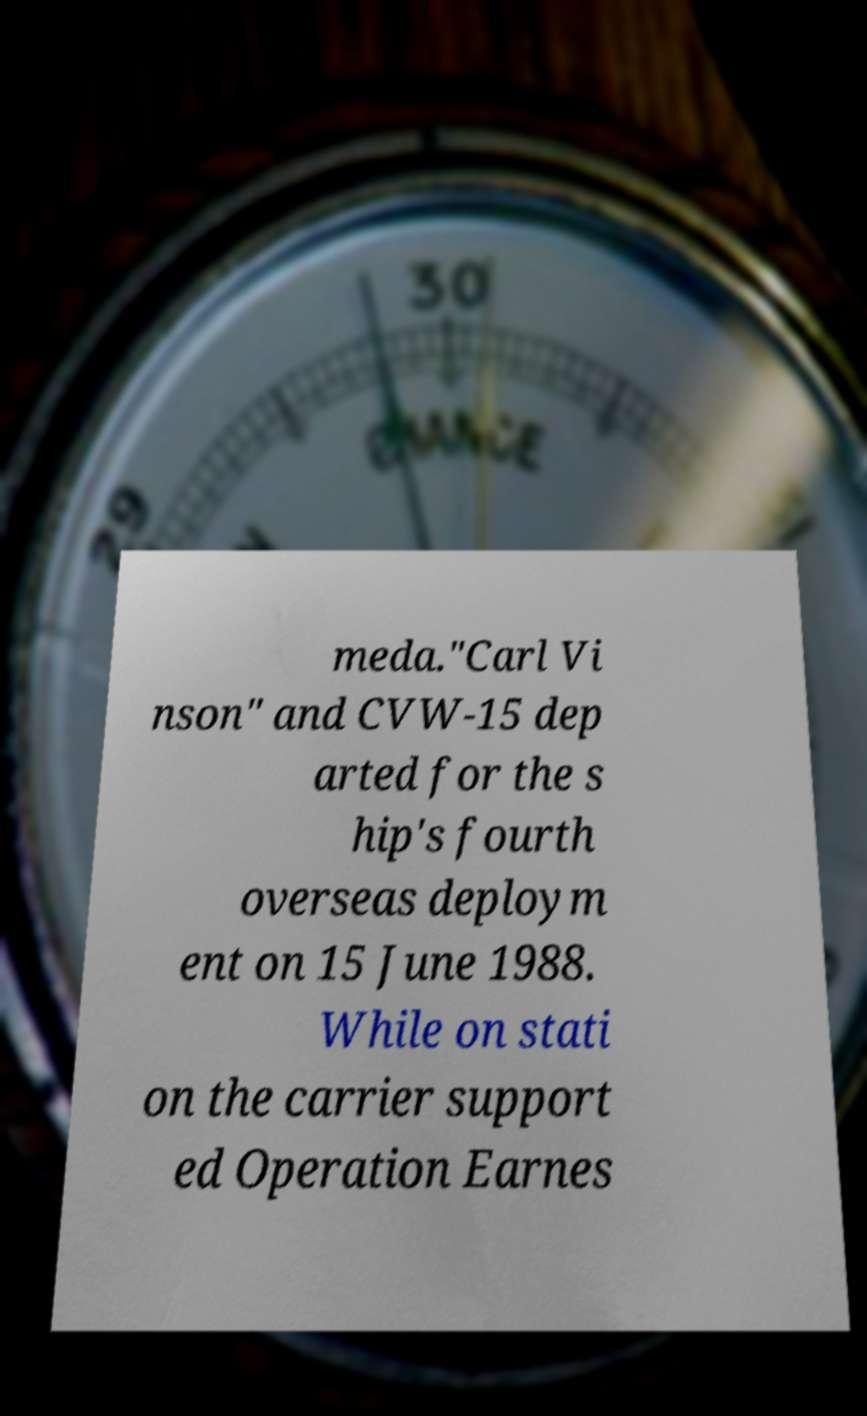Please identify and transcribe the text found in this image. meda."Carl Vi nson" and CVW-15 dep arted for the s hip's fourth overseas deploym ent on 15 June 1988. While on stati on the carrier support ed Operation Earnes 